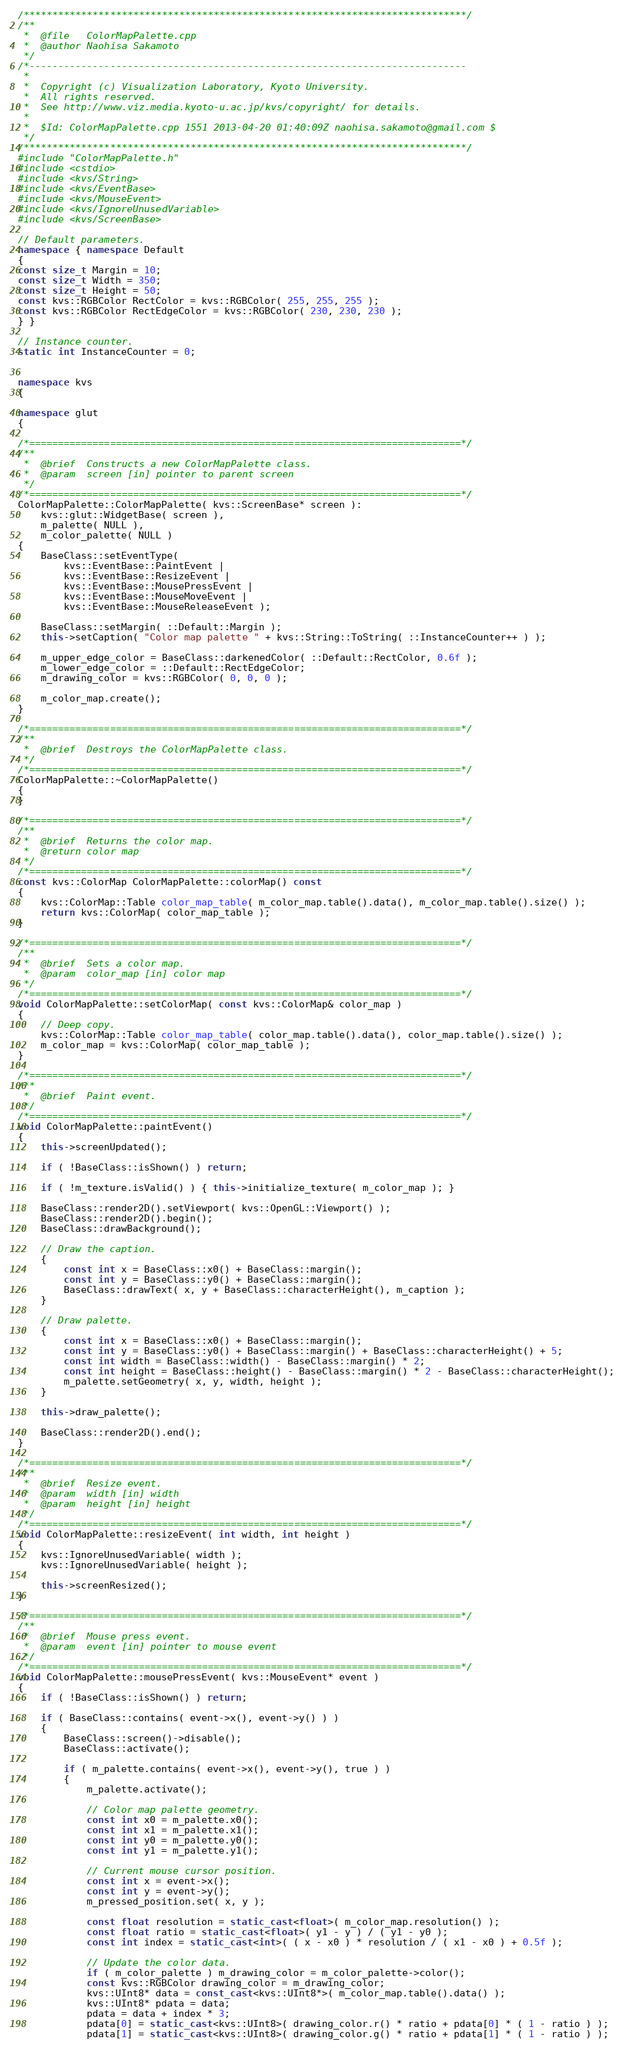<code> <loc_0><loc_0><loc_500><loc_500><_C++_>/*****************************************************************************/
/**
 *  @file   ColorMapPalette.cpp
 *  @author Naohisa Sakamoto
 */
/*----------------------------------------------------------------------------
 *
 *  Copyright (c) Visualization Laboratory, Kyoto University.
 *  All rights reserved.
 *  See http://www.viz.media.kyoto-u.ac.jp/kvs/copyright/ for details.
 *
 *  $Id: ColorMapPalette.cpp 1551 2013-04-20 01:40:09Z naohisa.sakamoto@gmail.com $
 */
/*****************************************************************************/
#include "ColorMapPalette.h"
#include <cstdio>
#include <kvs/String>
#include <kvs/EventBase>
#include <kvs/MouseEvent>
#include <kvs/IgnoreUnusedVariable>
#include <kvs/ScreenBase>

// Default parameters.
namespace { namespace Default
{
const size_t Margin = 10;
const size_t Width = 350;
const size_t Height = 50;
const kvs::RGBColor RectColor = kvs::RGBColor( 255, 255, 255 );
const kvs::RGBColor RectEdgeColor = kvs::RGBColor( 230, 230, 230 );
} }

// Instance counter.
static int InstanceCounter = 0;


namespace kvs
{

namespace glut
{

/*===========================================================================*/
/**
 *  @brief  Constructs a new ColorMapPalette class.
 *  @param  screen [in] pointer to parent screen
 */
/*===========================================================================*/
ColorMapPalette::ColorMapPalette( kvs::ScreenBase* screen ):
    kvs::glut::WidgetBase( screen ),
    m_palette( NULL ),
    m_color_palette( NULL )
{
    BaseClass::setEventType(
        kvs::EventBase::PaintEvent |
        kvs::EventBase::ResizeEvent |
        kvs::EventBase::MousePressEvent |
        kvs::EventBase::MouseMoveEvent |
        kvs::EventBase::MouseReleaseEvent );

    BaseClass::setMargin( ::Default::Margin );
    this->setCaption( "Color map palette " + kvs::String::ToString( ::InstanceCounter++ ) );

    m_upper_edge_color = BaseClass::darkenedColor( ::Default::RectColor, 0.6f );
    m_lower_edge_color = ::Default::RectEdgeColor;
    m_drawing_color = kvs::RGBColor( 0, 0, 0 );

    m_color_map.create();
}

/*===========================================================================*/
/**
 *  @brief  Destroys the ColorMapPalette class.
 */
/*===========================================================================*/
ColorMapPalette::~ColorMapPalette()
{
}

/*===========================================================================*/
/**
 *  @brief  Returns the color map.
 *  @return color map
 */
/*===========================================================================*/
const kvs::ColorMap ColorMapPalette::colorMap() const
{
    kvs::ColorMap::Table color_map_table( m_color_map.table().data(), m_color_map.table().size() );
    return kvs::ColorMap( color_map_table );
}

/*===========================================================================*/
/**
 *  @brief  Sets a color map.
 *  @param  color_map [in] color map
 */
/*===========================================================================*/
void ColorMapPalette::setColorMap( const kvs::ColorMap& color_map )
{
    // Deep copy.
    kvs::ColorMap::Table color_map_table( color_map.table().data(), color_map.table().size() );
    m_color_map = kvs::ColorMap( color_map_table );
}

/*===========================================================================*/
/**
 *  @brief  Paint event.
 */
/*===========================================================================*/
void ColorMapPalette::paintEvent()
{
    this->screenUpdated();

    if ( !BaseClass::isShown() ) return;

    if ( !m_texture.isValid() ) { this->initialize_texture( m_color_map ); }

    BaseClass::render2D().setViewport( kvs::OpenGL::Viewport() );
    BaseClass::render2D().begin();
    BaseClass::drawBackground();

    // Draw the caption.
    {
        const int x = BaseClass::x0() + BaseClass::margin();
        const int y = BaseClass::y0() + BaseClass::margin();
        BaseClass::drawText( x, y + BaseClass::characterHeight(), m_caption );
    }

    // Draw palette.
    {
        const int x = BaseClass::x0() + BaseClass::margin();
        const int y = BaseClass::y0() + BaseClass::margin() + BaseClass::characterHeight() + 5;
        const int width = BaseClass::width() - BaseClass::margin() * 2;
        const int height = BaseClass::height() - BaseClass::margin() * 2 - BaseClass::characterHeight();
        m_palette.setGeometry( x, y, width, height );
    }

    this->draw_palette();

    BaseClass::render2D().end();
}

/*===========================================================================*/
/**
 *  @brief  Resize event.
 *  @param  width [in] width
 *  @param  height [in] height
 */
/*===========================================================================*/
void ColorMapPalette::resizeEvent( int width, int height )
{
    kvs::IgnoreUnusedVariable( width );
    kvs::IgnoreUnusedVariable( height );

    this->screenResized();
}

/*===========================================================================*/
/**
 *  @brief  Mouse press event.
 *  @param  event [in] pointer to mouse event
 */
/*===========================================================================*/
void ColorMapPalette::mousePressEvent( kvs::MouseEvent* event )
{
    if ( !BaseClass::isShown() ) return;

    if ( BaseClass::contains( event->x(), event->y() ) )
    {
        BaseClass::screen()->disable();
        BaseClass::activate();

        if ( m_palette.contains( event->x(), event->y(), true ) )
        {
            m_palette.activate();

            // Color map palette geometry.
            const int x0 = m_palette.x0();
            const int x1 = m_palette.x1();
            const int y0 = m_palette.y0();
            const int y1 = m_palette.y1();

            // Current mouse cursor position.
            const int x = event->x();
            const int y = event->y();
            m_pressed_position.set( x, y );

            const float resolution = static_cast<float>( m_color_map.resolution() );
            const float ratio = static_cast<float>( y1 - y ) / ( y1 - y0 );
            const int index = static_cast<int>( ( x - x0 ) * resolution / ( x1 - x0 ) + 0.5f );

            // Update the color data.
            if ( m_color_palette ) m_drawing_color = m_color_palette->color();
            const kvs::RGBColor drawing_color = m_drawing_color;
            kvs::UInt8* data = const_cast<kvs::UInt8*>( m_color_map.table().data() );
            kvs::UInt8* pdata = data;
            pdata = data + index * 3;
            pdata[0] = static_cast<kvs::UInt8>( drawing_color.r() * ratio + pdata[0] * ( 1 - ratio ) );
            pdata[1] = static_cast<kvs::UInt8>( drawing_color.g() * ratio + pdata[1] * ( 1 - ratio ) );</code> 